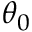Convert formula to latex. <formula><loc_0><loc_0><loc_500><loc_500>\theta _ { 0 }</formula> 